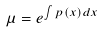Convert formula to latex. <formula><loc_0><loc_0><loc_500><loc_500>\mu = e ^ { \int p ( x ) d x }</formula> 